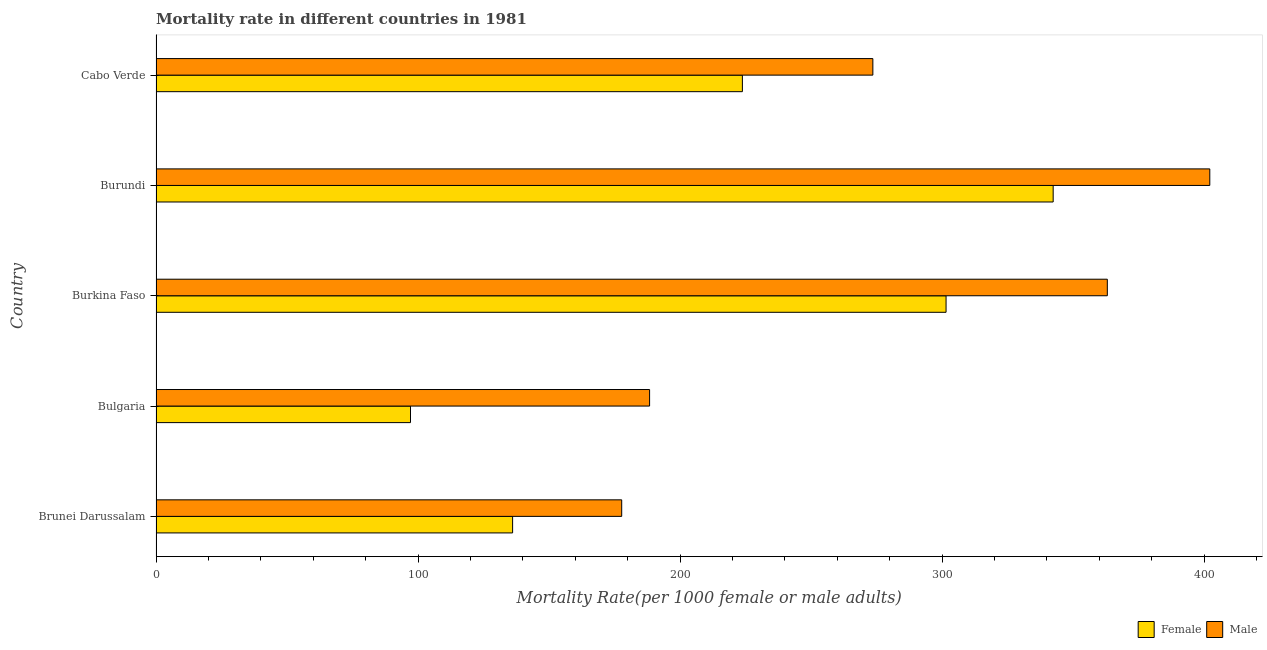How many different coloured bars are there?
Keep it short and to the point. 2. Are the number of bars on each tick of the Y-axis equal?
Ensure brevity in your answer.  Yes. How many bars are there on the 2nd tick from the top?
Offer a very short reply. 2. How many bars are there on the 3rd tick from the bottom?
Offer a very short reply. 2. What is the label of the 4th group of bars from the top?
Provide a short and direct response. Bulgaria. What is the female mortality rate in Bulgaria?
Your answer should be compact. 97.13. Across all countries, what is the maximum male mortality rate?
Offer a very short reply. 402.2. Across all countries, what is the minimum female mortality rate?
Offer a very short reply. 97.13. In which country was the female mortality rate maximum?
Ensure brevity in your answer.  Burundi. What is the total male mortality rate in the graph?
Offer a terse response. 1404.99. What is the difference between the female mortality rate in Burundi and that in Cabo Verde?
Your answer should be very brief. 118.62. What is the difference between the female mortality rate in Bulgaria and the male mortality rate in Brunei Darussalam?
Provide a short and direct response. -80.61. What is the average female mortality rate per country?
Provide a succinct answer. 220.19. What is the difference between the male mortality rate and female mortality rate in Burkina Faso?
Your response must be concise. 61.55. What is the ratio of the male mortality rate in Brunei Darussalam to that in Cabo Verde?
Keep it short and to the point. 0.65. What is the difference between the highest and the second highest female mortality rate?
Your answer should be compact. 40.88. What is the difference between the highest and the lowest male mortality rate?
Give a very brief answer. 224.46. What does the 2nd bar from the top in Burundi represents?
Your answer should be compact. Female. What does the 1st bar from the bottom in Burundi represents?
Your response must be concise. Female. Are all the bars in the graph horizontal?
Your answer should be compact. Yes. What is the difference between two consecutive major ticks on the X-axis?
Make the answer very short. 100. Where does the legend appear in the graph?
Keep it short and to the point. Bottom right. How are the legend labels stacked?
Your response must be concise. Horizontal. What is the title of the graph?
Give a very brief answer. Mortality rate in different countries in 1981. What is the label or title of the X-axis?
Make the answer very short. Mortality Rate(per 1000 female or male adults). What is the label or title of the Y-axis?
Your answer should be very brief. Country. What is the Mortality Rate(per 1000 female or male adults) in Female in Brunei Darussalam?
Provide a succinct answer. 136.1. What is the Mortality Rate(per 1000 female or male adults) in Male in Brunei Darussalam?
Your answer should be compact. 177.73. What is the Mortality Rate(per 1000 female or male adults) of Female in Bulgaria?
Ensure brevity in your answer.  97.13. What is the Mortality Rate(per 1000 female or male adults) of Male in Bulgaria?
Provide a succinct answer. 188.38. What is the Mortality Rate(per 1000 female or male adults) in Female in Burkina Faso?
Give a very brief answer. 301.53. What is the Mortality Rate(per 1000 female or male adults) of Male in Burkina Faso?
Your answer should be compact. 363.08. What is the Mortality Rate(per 1000 female or male adults) in Female in Burundi?
Your response must be concise. 342.42. What is the Mortality Rate(per 1000 female or male adults) of Male in Burundi?
Your answer should be compact. 402.2. What is the Mortality Rate(per 1000 female or male adults) in Female in Cabo Verde?
Give a very brief answer. 223.8. What is the Mortality Rate(per 1000 female or male adults) in Male in Cabo Verde?
Your answer should be very brief. 273.6. Across all countries, what is the maximum Mortality Rate(per 1000 female or male adults) in Female?
Your response must be concise. 342.42. Across all countries, what is the maximum Mortality Rate(per 1000 female or male adults) of Male?
Your answer should be very brief. 402.2. Across all countries, what is the minimum Mortality Rate(per 1000 female or male adults) in Female?
Keep it short and to the point. 97.13. Across all countries, what is the minimum Mortality Rate(per 1000 female or male adults) of Male?
Keep it short and to the point. 177.73. What is the total Mortality Rate(per 1000 female or male adults) in Female in the graph?
Offer a terse response. 1100.97. What is the total Mortality Rate(per 1000 female or male adults) of Male in the graph?
Your answer should be compact. 1404.99. What is the difference between the Mortality Rate(per 1000 female or male adults) in Female in Brunei Darussalam and that in Bulgaria?
Ensure brevity in your answer.  38.97. What is the difference between the Mortality Rate(per 1000 female or male adults) of Male in Brunei Darussalam and that in Bulgaria?
Offer a terse response. -10.65. What is the difference between the Mortality Rate(per 1000 female or male adults) of Female in Brunei Darussalam and that in Burkina Faso?
Offer a terse response. -165.43. What is the difference between the Mortality Rate(per 1000 female or male adults) in Male in Brunei Darussalam and that in Burkina Faso?
Give a very brief answer. -185.35. What is the difference between the Mortality Rate(per 1000 female or male adults) of Female in Brunei Darussalam and that in Burundi?
Offer a terse response. -206.32. What is the difference between the Mortality Rate(per 1000 female or male adults) of Male in Brunei Darussalam and that in Burundi?
Offer a very short reply. -224.46. What is the difference between the Mortality Rate(per 1000 female or male adults) of Female in Brunei Darussalam and that in Cabo Verde?
Provide a succinct answer. -87.7. What is the difference between the Mortality Rate(per 1000 female or male adults) in Male in Brunei Darussalam and that in Cabo Verde?
Provide a short and direct response. -95.86. What is the difference between the Mortality Rate(per 1000 female or male adults) in Female in Bulgaria and that in Burkina Faso?
Keep it short and to the point. -204.4. What is the difference between the Mortality Rate(per 1000 female or male adults) in Male in Bulgaria and that in Burkina Faso?
Make the answer very short. -174.7. What is the difference between the Mortality Rate(per 1000 female or male adults) in Female in Bulgaria and that in Burundi?
Provide a short and direct response. -245.29. What is the difference between the Mortality Rate(per 1000 female or male adults) of Male in Bulgaria and that in Burundi?
Ensure brevity in your answer.  -213.81. What is the difference between the Mortality Rate(per 1000 female or male adults) of Female in Bulgaria and that in Cabo Verde?
Provide a succinct answer. -126.67. What is the difference between the Mortality Rate(per 1000 female or male adults) in Male in Bulgaria and that in Cabo Verde?
Offer a very short reply. -85.22. What is the difference between the Mortality Rate(per 1000 female or male adults) in Female in Burkina Faso and that in Burundi?
Provide a succinct answer. -40.88. What is the difference between the Mortality Rate(per 1000 female or male adults) in Male in Burkina Faso and that in Burundi?
Make the answer very short. -39.11. What is the difference between the Mortality Rate(per 1000 female or male adults) of Female in Burkina Faso and that in Cabo Verde?
Make the answer very short. 77.73. What is the difference between the Mortality Rate(per 1000 female or male adults) in Male in Burkina Faso and that in Cabo Verde?
Make the answer very short. 89.49. What is the difference between the Mortality Rate(per 1000 female or male adults) of Female in Burundi and that in Cabo Verde?
Your answer should be very brief. 118.62. What is the difference between the Mortality Rate(per 1000 female or male adults) of Male in Burundi and that in Cabo Verde?
Ensure brevity in your answer.  128.6. What is the difference between the Mortality Rate(per 1000 female or male adults) of Female in Brunei Darussalam and the Mortality Rate(per 1000 female or male adults) of Male in Bulgaria?
Your response must be concise. -52.28. What is the difference between the Mortality Rate(per 1000 female or male adults) in Female in Brunei Darussalam and the Mortality Rate(per 1000 female or male adults) in Male in Burkina Faso?
Keep it short and to the point. -226.99. What is the difference between the Mortality Rate(per 1000 female or male adults) in Female in Brunei Darussalam and the Mortality Rate(per 1000 female or male adults) in Male in Burundi?
Your answer should be very brief. -266.1. What is the difference between the Mortality Rate(per 1000 female or male adults) in Female in Brunei Darussalam and the Mortality Rate(per 1000 female or male adults) in Male in Cabo Verde?
Offer a terse response. -137.5. What is the difference between the Mortality Rate(per 1000 female or male adults) in Female in Bulgaria and the Mortality Rate(per 1000 female or male adults) in Male in Burkina Faso?
Keep it short and to the point. -265.95. What is the difference between the Mortality Rate(per 1000 female or male adults) in Female in Bulgaria and the Mortality Rate(per 1000 female or male adults) in Male in Burundi?
Offer a terse response. -305.07. What is the difference between the Mortality Rate(per 1000 female or male adults) in Female in Bulgaria and the Mortality Rate(per 1000 female or male adults) in Male in Cabo Verde?
Keep it short and to the point. -176.47. What is the difference between the Mortality Rate(per 1000 female or male adults) in Female in Burkina Faso and the Mortality Rate(per 1000 female or male adults) in Male in Burundi?
Offer a very short reply. -100.66. What is the difference between the Mortality Rate(per 1000 female or male adults) of Female in Burkina Faso and the Mortality Rate(per 1000 female or male adults) of Male in Cabo Verde?
Offer a terse response. 27.93. What is the difference between the Mortality Rate(per 1000 female or male adults) of Female in Burundi and the Mortality Rate(per 1000 female or male adults) of Male in Cabo Verde?
Offer a very short reply. 68.82. What is the average Mortality Rate(per 1000 female or male adults) of Female per country?
Your response must be concise. 220.19. What is the average Mortality Rate(per 1000 female or male adults) of Male per country?
Provide a short and direct response. 281. What is the difference between the Mortality Rate(per 1000 female or male adults) in Female and Mortality Rate(per 1000 female or male adults) in Male in Brunei Darussalam?
Keep it short and to the point. -41.64. What is the difference between the Mortality Rate(per 1000 female or male adults) in Female and Mortality Rate(per 1000 female or male adults) in Male in Bulgaria?
Offer a terse response. -91.25. What is the difference between the Mortality Rate(per 1000 female or male adults) of Female and Mortality Rate(per 1000 female or male adults) of Male in Burkina Faso?
Keep it short and to the point. -61.55. What is the difference between the Mortality Rate(per 1000 female or male adults) of Female and Mortality Rate(per 1000 female or male adults) of Male in Burundi?
Provide a succinct answer. -59.78. What is the difference between the Mortality Rate(per 1000 female or male adults) in Female and Mortality Rate(per 1000 female or male adults) in Male in Cabo Verde?
Keep it short and to the point. -49.8. What is the ratio of the Mortality Rate(per 1000 female or male adults) in Female in Brunei Darussalam to that in Bulgaria?
Ensure brevity in your answer.  1.4. What is the ratio of the Mortality Rate(per 1000 female or male adults) in Male in Brunei Darussalam to that in Bulgaria?
Give a very brief answer. 0.94. What is the ratio of the Mortality Rate(per 1000 female or male adults) in Female in Brunei Darussalam to that in Burkina Faso?
Keep it short and to the point. 0.45. What is the ratio of the Mortality Rate(per 1000 female or male adults) of Male in Brunei Darussalam to that in Burkina Faso?
Ensure brevity in your answer.  0.49. What is the ratio of the Mortality Rate(per 1000 female or male adults) in Female in Brunei Darussalam to that in Burundi?
Offer a very short reply. 0.4. What is the ratio of the Mortality Rate(per 1000 female or male adults) of Male in Brunei Darussalam to that in Burundi?
Your answer should be compact. 0.44. What is the ratio of the Mortality Rate(per 1000 female or male adults) of Female in Brunei Darussalam to that in Cabo Verde?
Your response must be concise. 0.61. What is the ratio of the Mortality Rate(per 1000 female or male adults) of Male in Brunei Darussalam to that in Cabo Verde?
Your response must be concise. 0.65. What is the ratio of the Mortality Rate(per 1000 female or male adults) of Female in Bulgaria to that in Burkina Faso?
Your response must be concise. 0.32. What is the ratio of the Mortality Rate(per 1000 female or male adults) of Male in Bulgaria to that in Burkina Faso?
Provide a succinct answer. 0.52. What is the ratio of the Mortality Rate(per 1000 female or male adults) in Female in Bulgaria to that in Burundi?
Keep it short and to the point. 0.28. What is the ratio of the Mortality Rate(per 1000 female or male adults) of Male in Bulgaria to that in Burundi?
Offer a very short reply. 0.47. What is the ratio of the Mortality Rate(per 1000 female or male adults) of Female in Bulgaria to that in Cabo Verde?
Give a very brief answer. 0.43. What is the ratio of the Mortality Rate(per 1000 female or male adults) in Male in Bulgaria to that in Cabo Verde?
Offer a very short reply. 0.69. What is the ratio of the Mortality Rate(per 1000 female or male adults) in Female in Burkina Faso to that in Burundi?
Offer a very short reply. 0.88. What is the ratio of the Mortality Rate(per 1000 female or male adults) in Male in Burkina Faso to that in Burundi?
Provide a short and direct response. 0.9. What is the ratio of the Mortality Rate(per 1000 female or male adults) in Female in Burkina Faso to that in Cabo Verde?
Give a very brief answer. 1.35. What is the ratio of the Mortality Rate(per 1000 female or male adults) in Male in Burkina Faso to that in Cabo Verde?
Keep it short and to the point. 1.33. What is the ratio of the Mortality Rate(per 1000 female or male adults) of Female in Burundi to that in Cabo Verde?
Offer a terse response. 1.53. What is the ratio of the Mortality Rate(per 1000 female or male adults) of Male in Burundi to that in Cabo Verde?
Give a very brief answer. 1.47. What is the difference between the highest and the second highest Mortality Rate(per 1000 female or male adults) of Female?
Your answer should be compact. 40.88. What is the difference between the highest and the second highest Mortality Rate(per 1000 female or male adults) in Male?
Your answer should be compact. 39.11. What is the difference between the highest and the lowest Mortality Rate(per 1000 female or male adults) of Female?
Give a very brief answer. 245.29. What is the difference between the highest and the lowest Mortality Rate(per 1000 female or male adults) in Male?
Offer a terse response. 224.46. 